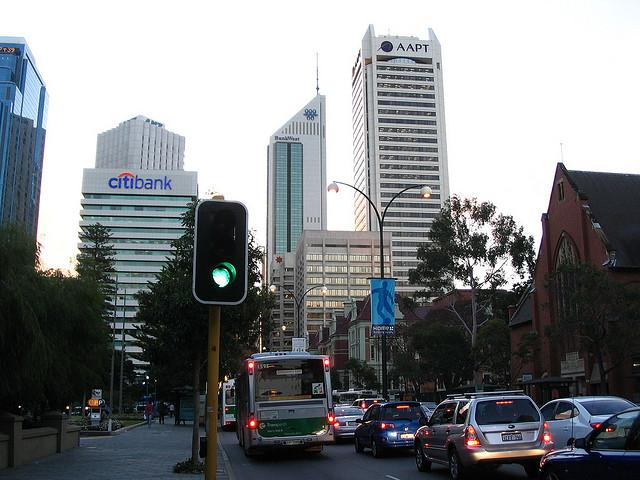Who designed the first building's logo? Please explain your reasoning. paula scher. The citibank logo was designed in 1998 by paula scher, a well known designer. 